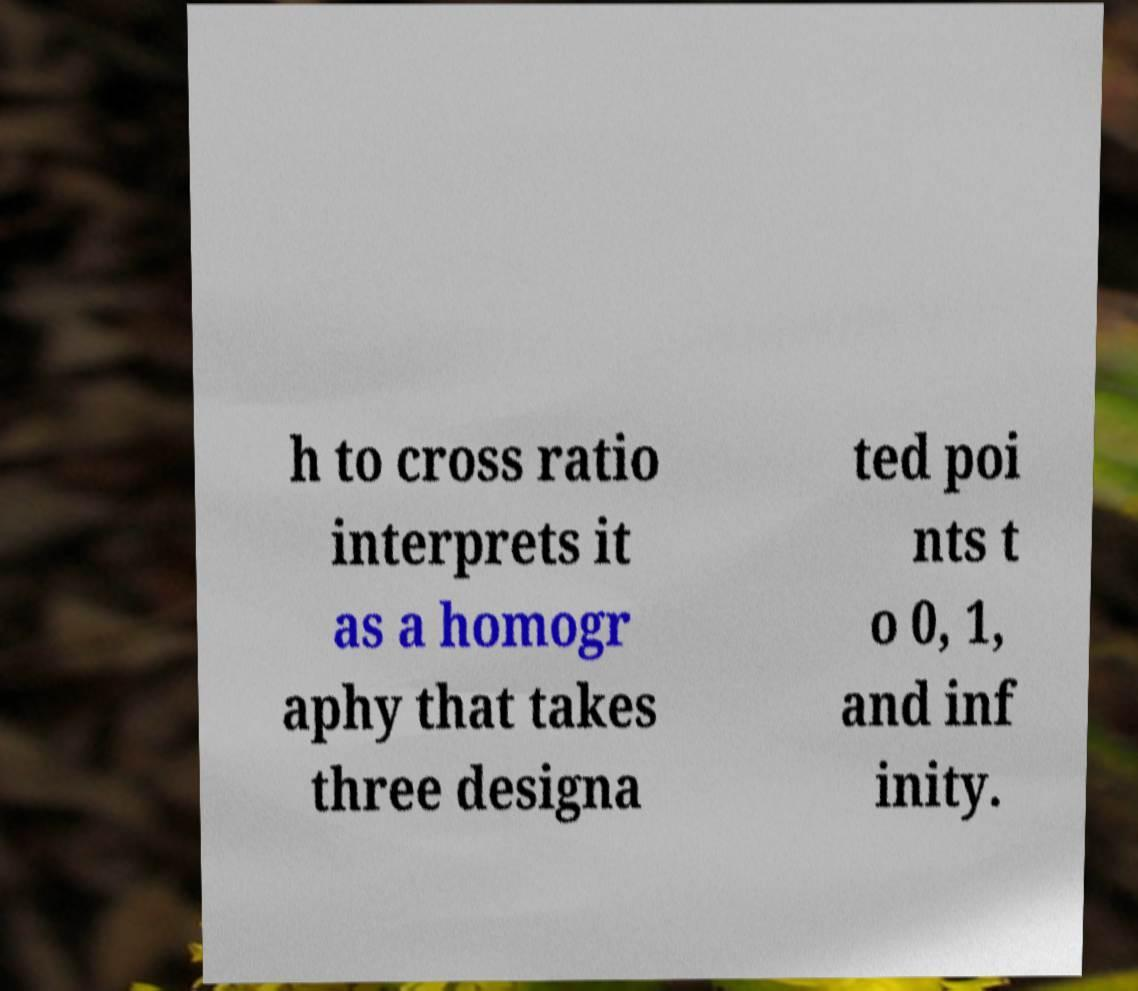For documentation purposes, I need the text within this image transcribed. Could you provide that? h to cross ratio interprets it as a homogr aphy that takes three designa ted poi nts t o 0, 1, and inf inity. 